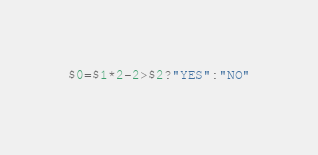<code> <loc_0><loc_0><loc_500><loc_500><_Awk_>$0=$1*2-2>$2?"YES":"NO"</code> 